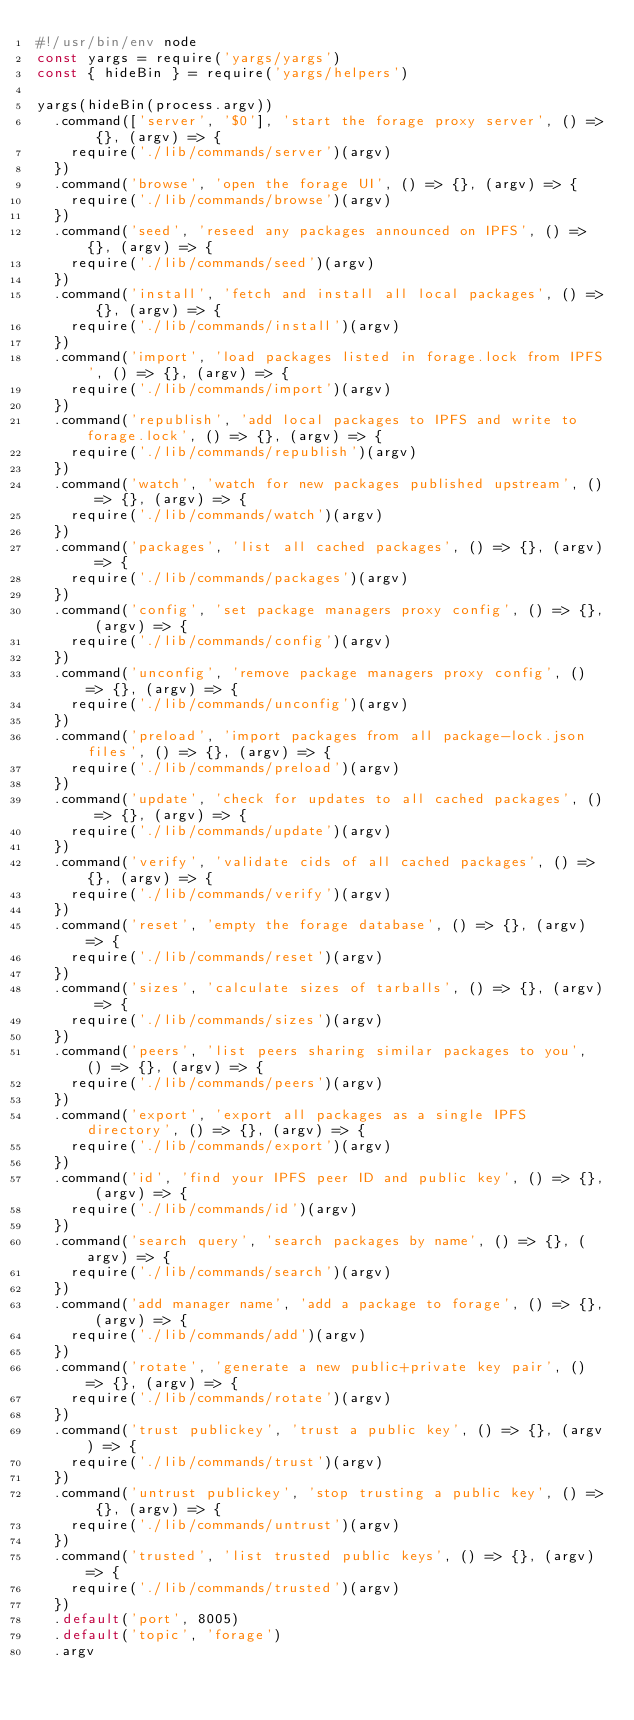<code> <loc_0><loc_0><loc_500><loc_500><_JavaScript_>#!/usr/bin/env node
const yargs = require('yargs/yargs')
const { hideBin } = require('yargs/helpers')

yargs(hideBin(process.argv))
  .command(['server', '$0'], 'start the forage proxy server', () => {}, (argv) => {
    require('./lib/commands/server')(argv)
  })
  .command('browse', 'open the forage UI', () => {}, (argv) => {
    require('./lib/commands/browse')(argv)
  })
  .command('seed', 'reseed any packages announced on IPFS', () => {}, (argv) => {
    require('./lib/commands/seed')(argv)
  })
  .command('install', 'fetch and install all local packages', () => {}, (argv) => {
    require('./lib/commands/install')(argv)
  })
  .command('import', 'load packages listed in forage.lock from IPFS', () => {}, (argv) => {
    require('./lib/commands/import')(argv)
  })
  .command('republish', 'add local packages to IPFS and write to forage.lock', () => {}, (argv) => {
    require('./lib/commands/republish')(argv)
  })
  .command('watch', 'watch for new packages published upstream', () => {}, (argv) => {
    require('./lib/commands/watch')(argv)
  })
  .command('packages', 'list all cached packages', () => {}, (argv) => {
    require('./lib/commands/packages')(argv)
  })
  .command('config', 'set package managers proxy config', () => {}, (argv) => {
    require('./lib/commands/config')(argv)
  })
  .command('unconfig', 'remove package managers proxy config', () => {}, (argv) => {
    require('./lib/commands/unconfig')(argv)
  })
  .command('preload', 'import packages from all package-lock.json files', () => {}, (argv) => {
    require('./lib/commands/preload')(argv)
  })
  .command('update', 'check for updates to all cached packages', () => {}, (argv) => {
    require('./lib/commands/update')(argv)
  })
  .command('verify', 'validate cids of all cached packages', () => {}, (argv) => {
    require('./lib/commands/verify')(argv)
  })
  .command('reset', 'empty the forage database', () => {}, (argv) => {
    require('./lib/commands/reset')(argv)
  })
  .command('sizes', 'calculate sizes of tarballs', () => {}, (argv) => {
    require('./lib/commands/sizes')(argv)
  })
  .command('peers', 'list peers sharing similar packages to you', () => {}, (argv) => {
    require('./lib/commands/peers')(argv)
  })
  .command('export', 'export all packages as a single IPFS directory', () => {}, (argv) => {
    require('./lib/commands/export')(argv)
  })
  .command('id', 'find your IPFS peer ID and public key', () => {}, (argv) => {
    require('./lib/commands/id')(argv)
  })
  .command('search query', 'search packages by name', () => {}, (argv) => {
    require('./lib/commands/search')(argv)
  })
  .command('add manager name', 'add a package to forage', () => {}, (argv) => {
    require('./lib/commands/add')(argv)
  })
  .command('rotate', 'generate a new public+private key pair', () => {}, (argv) => {
    require('./lib/commands/rotate')(argv)
  })
  .command('trust publickey', 'trust a public key', () => {}, (argv) => {
    require('./lib/commands/trust')(argv)
  })
  .command('untrust publickey', 'stop trusting a public key', () => {}, (argv) => {
    require('./lib/commands/untrust')(argv)
  })
  .command('trusted', 'list trusted public keys', () => {}, (argv) => {
    require('./lib/commands/trusted')(argv)
  })
  .default('port', 8005)
  .default('topic', 'forage')
  .argv
</code> 